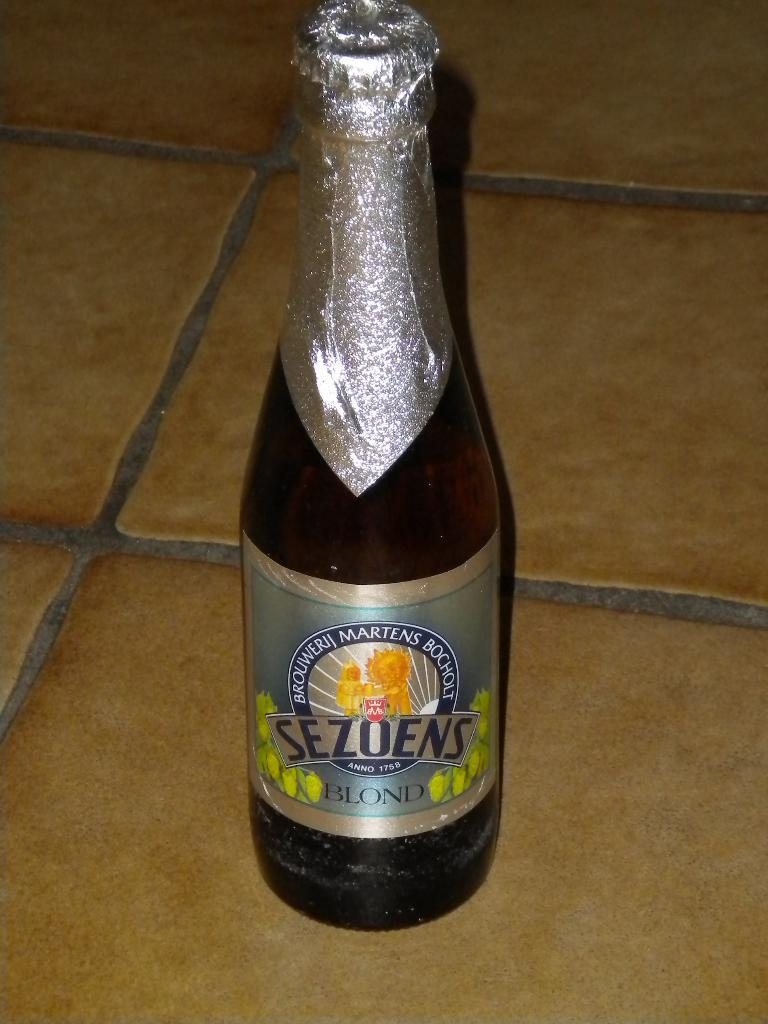<image>
Relay a brief, clear account of the picture shown. A bottle of Sezoens Blond is placed on a tile floor. 